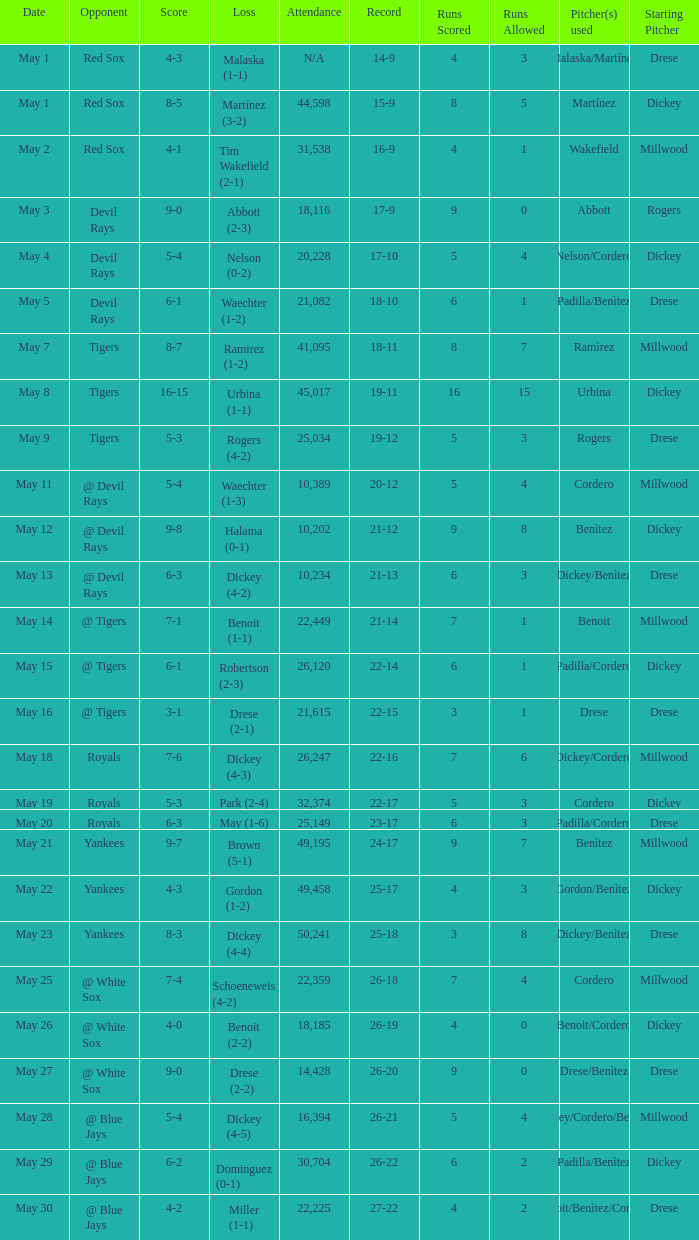What was the record at the game attended by 10,389? 20-12. 